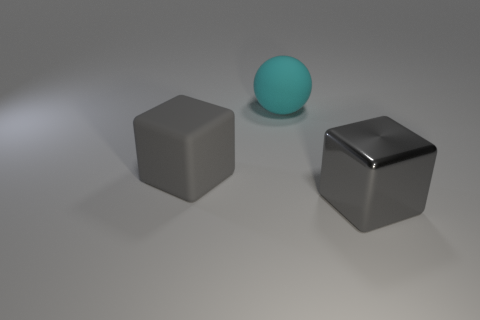There is a big sphere; does it have the same color as the large cube that is to the right of the rubber block?
Make the answer very short. No. Is the number of big brown balls greater than the number of big gray objects?
Provide a succinct answer. No. What color is the big ball?
Provide a short and direct response. Cyan. There is a rubber object in front of the big cyan thing; is its color the same as the big ball?
Offer a terse response. No. What material is the other big cube that is the same color as the rubber cube?
Make the answer very short. Metal. How many rubber blocks are the same color as the big metallic cube?
Ensure brevity in your answer.  1. There is a gray thing right of the big sphere; is its shape the same as the cyan object?
Give a very brief answer. No. Are there fewer matte things that are to the right of the large metal cube than large metal blocks behind the big matte cube?
Make the answer very short. No. What is the big block right of the big rubber block made of?
Your answer should be compact. Metal. The object that is the same color as the rubber cube is what size?
Your response must be concise. Large. 